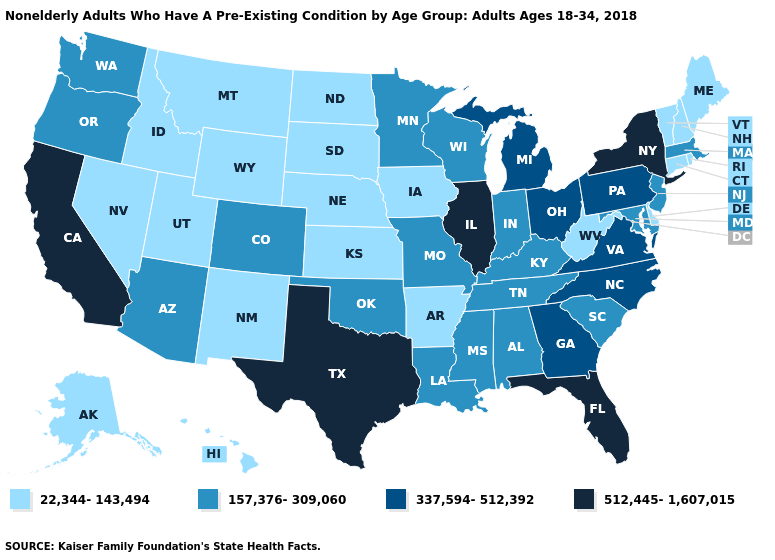Does the map have missing data?
Short answer required. No. What is the value of Delaware?
Be succinct. 22,344-143,494. What is the value of Louisiana?
Be succinct. 157,376-309,060. Does Minnesota have the same value as Maryland?
Concise answer only. Yes. Does Massachusetts have a lower value than Iowa?
Quick response, please. No. Name the states that have a value in the range 157,376-309,060?
Give a very brief answer. Alabama, Arizona, Colorado, Indiana, Kentucky, Louisiana, Maryland, Massachusetts, Minnesota, Mississippi, Missouri, New Jersey, Oklahoma, Oregon, South Carolina, Tennessee, Washington, Wisconsin. What is the value of Arizona?
Be succinct. 157,376-309,060. Name the states that have a value in the range 337,594-512,392?
Keep it brief. Georgia, Michigan, North Carolina, Ohio, Pennsylvania, Virginia. Does the map have missing data?
Keep it brief. No. Name the states that have a value in the range 512,445-1,607,015?
Keep it brief. California, Florida, Illinois, New York, Texas. What is the highest value in states that border Utah?
Keep it brief. 157,376-309,060. Does the map have missing data?
Give a very brief answer. No. What is the value of Nevada?
Give a very brief answer. 22,344-143,494. What is the value of Ohio?
Short answer required. 337,594-512,392. What is the value of Alabama?
Write a very short answer. 157,376-309,060. 